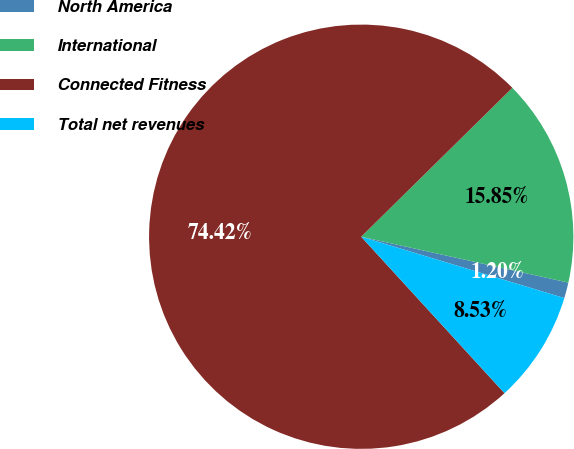Convert chart. <chart><loc_0><loc_0><loc_500><loc_500><pie_chart><fcel>North America<fcel>International<fcel>Connected Fitness<fcel>Total net revenues<nl><fcel>1.2%<fcel>15.85%<fcel>74.42%<fcel>8.53%<nl></chart> 